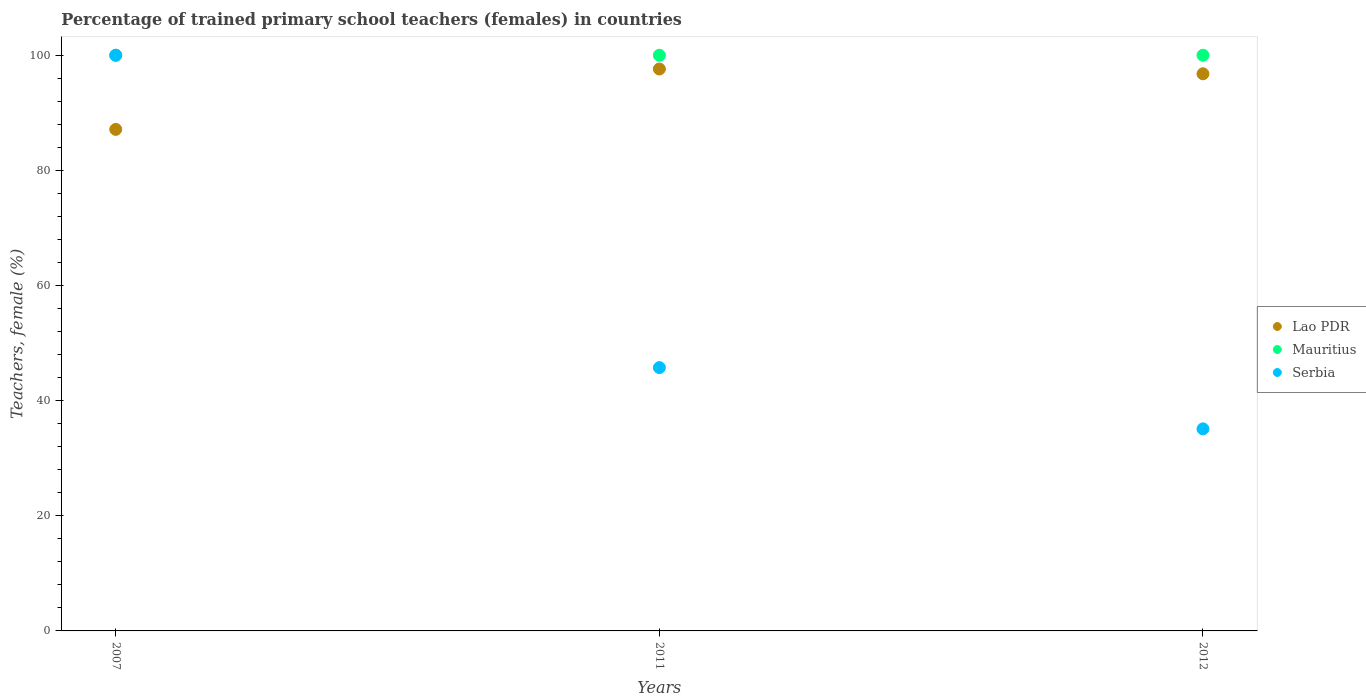How many different coloured dotlines are there?
Make the answer very short. 3. What is the percentage of trained primary school teachers (females) in Lao PDR in 2007?
Give a very brief answer. 87.12. Across all years, what is the maximum percentage of trained primary school teachers (females) in Lao PDR?
Offer a very short reply. 97.61. In which year was the percentage of trained primary school teachers (females) in Mauritius maximum?
Ensure brevity in your answer.  2007. What is the total percentage of trained primary school teachers (females) in Mauritius in the graph?
Ensure brevity in your answer.  300. What is the difference between the percentage of trained primary school teachers (females) in Serbia in 2007 and that in 2012?
Your response must be concise. 64.9. What is the difference between the percentage of trained primary school teachers (females) in Lao PDR in 2011 and the percentage of trained primary school teachers (females) in Serbia in 2012?
Your answer should be compact. 62.51. What is the average percentage of trained primary school teachers (females) in Serbia per year?
Offer a very short reply. 60.28. In the year 2012, what is the difference between the percentage of trained primary school teachers (females) in Serbia and percentage of trained primary school teachers (females) in Mauritius?
Offer a very short reply. -64.9. In how many years, is the percentage of trained primary school teachers (females) in Serbia greater than 88 %?
Offer a very short reply. 1. What is the ratio of the percentage of trained primary school teachers (females) in Lao PDR in 2007 to that in 2012?
Provide a succinct answer. 0.9. What is the difference between the highest and the second highest percentage of trained primary school teachers (females) in Lao PDR?
Your response must be concise. 0.83. In how many years, is the percentage of trained primary school teachers (females) in Mauritius greater than the average percentage of trained primary school teachers (females) in Mauritius taken over all years?
Your answer should be compact. 0. Is the sum of the percentage of trained primary school teachers (females) in Mauritius in 2011 and 2012 greater than the maximum percentage of trained primary school teachers (females) in Lao PDR across all years?
Ensure brevity in your answer.  Yes. Is the percentage of trained primary school teachers (females) in Mauritius strictly greater than the percentage of trained primary school teachers (females) in Serbia over the years?
Keep it short and to the point. No. Is the percentage of trained primary school teachers (females) in Lao PDR strictly less than the percentage of trained primary school teachers (females) in Mauritius over the years?
Provide a short and direct response. Yes. How many years are there in the graph?
Provide a short and direct response. 3. What is the difference between two consecutive major ticks on the Y-axis?
Ensure brevity in your answer.  20. Are the values on the major ticks of Y-axis written in scientific E-notation?
Keep it short and to the point. No. Does the graph contain any zero values?
Provide a short and direct response. No. Where does the legend appear in the graph?
Provide a short and direct response. Center right. How are the legend labels stacked?
Provide a succinct answer. Vertical. What is the title of the graph?
Keep it short and to the point. Percentage of trained primary school teachers (females) in countries. Does "Grenada" appear as one of the legend labels in the graph?
Give a very brief answer. No. What is the label or title of the X-axis?
Offer a very short reply. Years. What is the label or title of the Y-axis?
Provide a succinct answer. Teachers, female (%). What is the Teachers, female (%) in Lao PDR in 2007?
Provide a succinct answer. 87.12. What is the Teachers, female (%) in Mauritius in 2007?
Provide a succinct answer. 100. What is the Teachers, female (%) in Serbia in 2007?
Make the answer very short. 100. What is the Teachers, female (%) in Lao PDR in 2011?
Offer a terse response. 97.61. What is the Teachers, female (%) of Mauritius in 2011?
Offer a terse response. 100. What is the Teachers, female (%) of Serbia in 2011?
Provide a short and direct response. 45.74. What is the Teachers, female (%) of Lao PDR in 2012?
Keep it short and to the point. 96.78. What is the Teachers, female (%) in Mauritius in 2012?
Keep it short and to the point. 100. What is the Teachers, female (%) of Serbia in 2012?
Offer a very short reply. 35.1. Across all years, what is the maximum Teachers, female (%) in Lao PDR?
Give a very brief answer. 97.61. Across all years, what is the maximum Teachers, female (%) in Mauritius?
Your response must be concise. 100. Across all years, what is the maximum Teachers, female (%) in Serbia?
Offer a terse response. 100. Across all years, what is the minimum Teachers, female (%) in Lao PDR?
Your answer should be compact. 87.12. Across all years, what is the minimum Teachers, female (%) of Serbia?
Ensure brevity in your answer.  35.1. What is the total Teachers, female (%) in Lao PDR in the graph?
Give a very brief answer. 281.51. What is the total Teachers, female (%) of Mauritius in the graph?
Make the answer very short. 300. What is the total Teachers, female (%) of Serbia in the graph?
Keep it short and to the point. 180.84. What is the difference between the Teachers, female (%) of Lao PDR in 2007 and that in 2011?
Your response must be concise. -10.49. What is the difference between the Teachers, female (%) in Mauritius in 2007 and that in 2011?
Offer a very short reply. 0. What is the difference between the Teachers, female (%) in Serbia in 2007 and that in 2011?
Offer a terse response. 54.26. What is the difference between the Teachers, female (%) of Lao PDR in 2007 and that in 2012?
Ensure brevity in your answer.  -9.66. What is the difference between the Teachers, female (%) in Serbia in 2007 and that in 2012?
Ensure brevity in your answer.  64.9. What is the difference between the Teachers, female (%) in Lao PDR in 2011 and that in 2012?
Give a very brief answer. 0.83. What is the difference between the Teachers, female (%) in Serbia in 2011 and that in 2012?
Your response must be concise. 10.64. What is the difference between the Teachers, female (%) of Lao PDR in 2007 and the Teachers, female (%) of Mauritius in 2011?
Your answer should be very brief. -12.88. What is the difference between the Teachers, female (%) of Lao PDR in 2007 and the Teachers, female (%) of Serbia in 2011?
Your response must be concise. 41.38. What is the difference between the Teachers, female (%) in Mauritius in 2007 and the Teachers, female (%) in Serbia in 2011?
Provide a short and direct response. 54.26. What is the difference between the Teachers, female (%) in Lao PDR in 2007 and the Teachers, female (%) in Mauritius in 2012?
Offer a terse response. -12.88. What is the difference between the Teachers, female (%) of Lao PDR in 2007 and the Teachers, female (%) of Serbia in 2012?
Make the answer very short. 52.02. What is the difference between the Teachers, female (%) of Mauritius in 2007 and the Teachers, female (%) of Serbia in 2012?
Your answer should be very brief. 64.9. What is the difference between the Teachers, female (%) in Lao PDR in 2011 and the Teachers, female (%) in Mauritius in 2012?
Provide a short and direct response. -2.39. What is the difference between the Teachers, female (%) of Lao PDR in 2011 and the Teachers, female (%) of Serbia in 2012?
Give a very brief answer. 62.51. What is the difference between the Teachers, female (%) of Mauritius in 2011 and the Teachers, female (%) of Serbia in 2012?
Provide a succinct answer. 64.9. What is the average Teachers, female (%) in Lao PDR per year?
Your answer should be compact. 93.84. What is the average Teachers, female (%) of Serbia per year?
Ensure brevity in your answer.  60.28. In the year 2007, what is the difference between the Teachers, female (%) of Lao PDR and Teachers, female (%) of Mauritius?
Offer a terse response. -12.88. In the year 2007, what is the difference between the Teachers, female (%) of Lao PDR and Teachers, female (%) of Serbia?
Provide a succinct answer. -12.88. In the year 2011, what is the difference between the Teachers, female (%) of Lao PDR and Teachers, female (%) of Mauritius?
Offer a terse response. -2.39. In the year 2011, what is the difference between the Teachers, female (%) of Lao PDR and Teachers, female (%) of Serbia?
Give a very brief answer. 51.87. In the year 2011, what is the difference between the Teachers, female (%) of Mauritius and Teachers, female (%) of Serbia?
Your answer should be compact. 54.26. In the year 2012, what is the difference between the Teachers, female (%) in Lao PDR and Teachers, female (%) in Mauritius?
Make the answer very short. -3.22. In the year 2012, what is the difference between the Teachers, female (%) in Lao PDR and Teachers, female (%) in Serbia?
Your answer should be compact. 61.68. In the year 2012, what is the difference between the Teachers, female (%) in Mauritius and Teachers, female (%) in Serbia?
Your response must be concise. 64.9. What is the ratio of the Teachers, female (%) in Lao PDR in 2007 to that in 2011?
Your answer should be very brief. 0.89. What is the ratio of the Teachers, female (%) of Serbia in 2007 to that in 2011?
Your answer should be very brief. 2.19. What is the ratio of the Teachers, female (%) of Lao PDR in 2007 to that in 2012?
Offer a terse response. 0.9. What is the ratio of the Teachers, female (%) of Mauritius in 2007 to that in 2012?
Give a very brief answer. 1. What is the ratio of the Teachers, female (%) in Serbia in 2007 to that in 2012?
Ensure brevity in your answer.  2.85. What is the ratio of the Teachers, female (%) of Lao PDR in 2011 to that in 2012?
Your answer should be very brief. 1.01. What is the ratio of the Teachers, female (%) in Mauritius in 2011 to that in 2012?
Offer a very short reply. 1. What is the ratio of the Teachers, female (%) of Serbia in 2011 to that in 2012?
Keep it short and to the point. 1.3. What is the difference between the highest and the second highest Teachers, female (%) of Lao PDR?
Your response must be concise. 0.83. What is the difference between the highest and the second highest Teachers, female (%) in Mauritius?
Your response must be concise. 0. What is the difference between the highest and the second highest Teachers, female (%) in Serbia?
Make the answer very short. 54.26. What is the difference between the highest and the lowest Teachers, female (%) in Lao PDR?
Make the answer very short. 10.49. What is the difference between the highest and the lowest Teachers, female (%) in Mauritius?
Your response must be concise. 0. What is the difference between the highest and the lowest Teachers, female (%) of Serbia?
Provide a succinct answer. 64.9. 